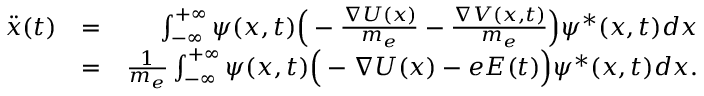Convert formula to latex. <formula><loc_0><loc_0><loc_500><loc_500>\begin{array} { r l r } { \ddot { x } ( t ) } & { = } & { \int _ { - \infty } ^ { + \infty } \psi ( x , t ) \left ( - \frac { \nabla U ( x ) } { m _ { e } } - \frac { \nabla V ( x , t ) } { m _ { e } } \right ) \psi ^ { * } ( x , t ) d x } \\ & { = } & { \frac { 1 } { m _ { e } } \int _ { - \infty } ^ { + \infty } \psi ( x , t ) \left ( - \nabla U ( x ) - e E ( t ) \right ) \psi ^ { * } ( x , t ) d x . } \end{array}</formula> 